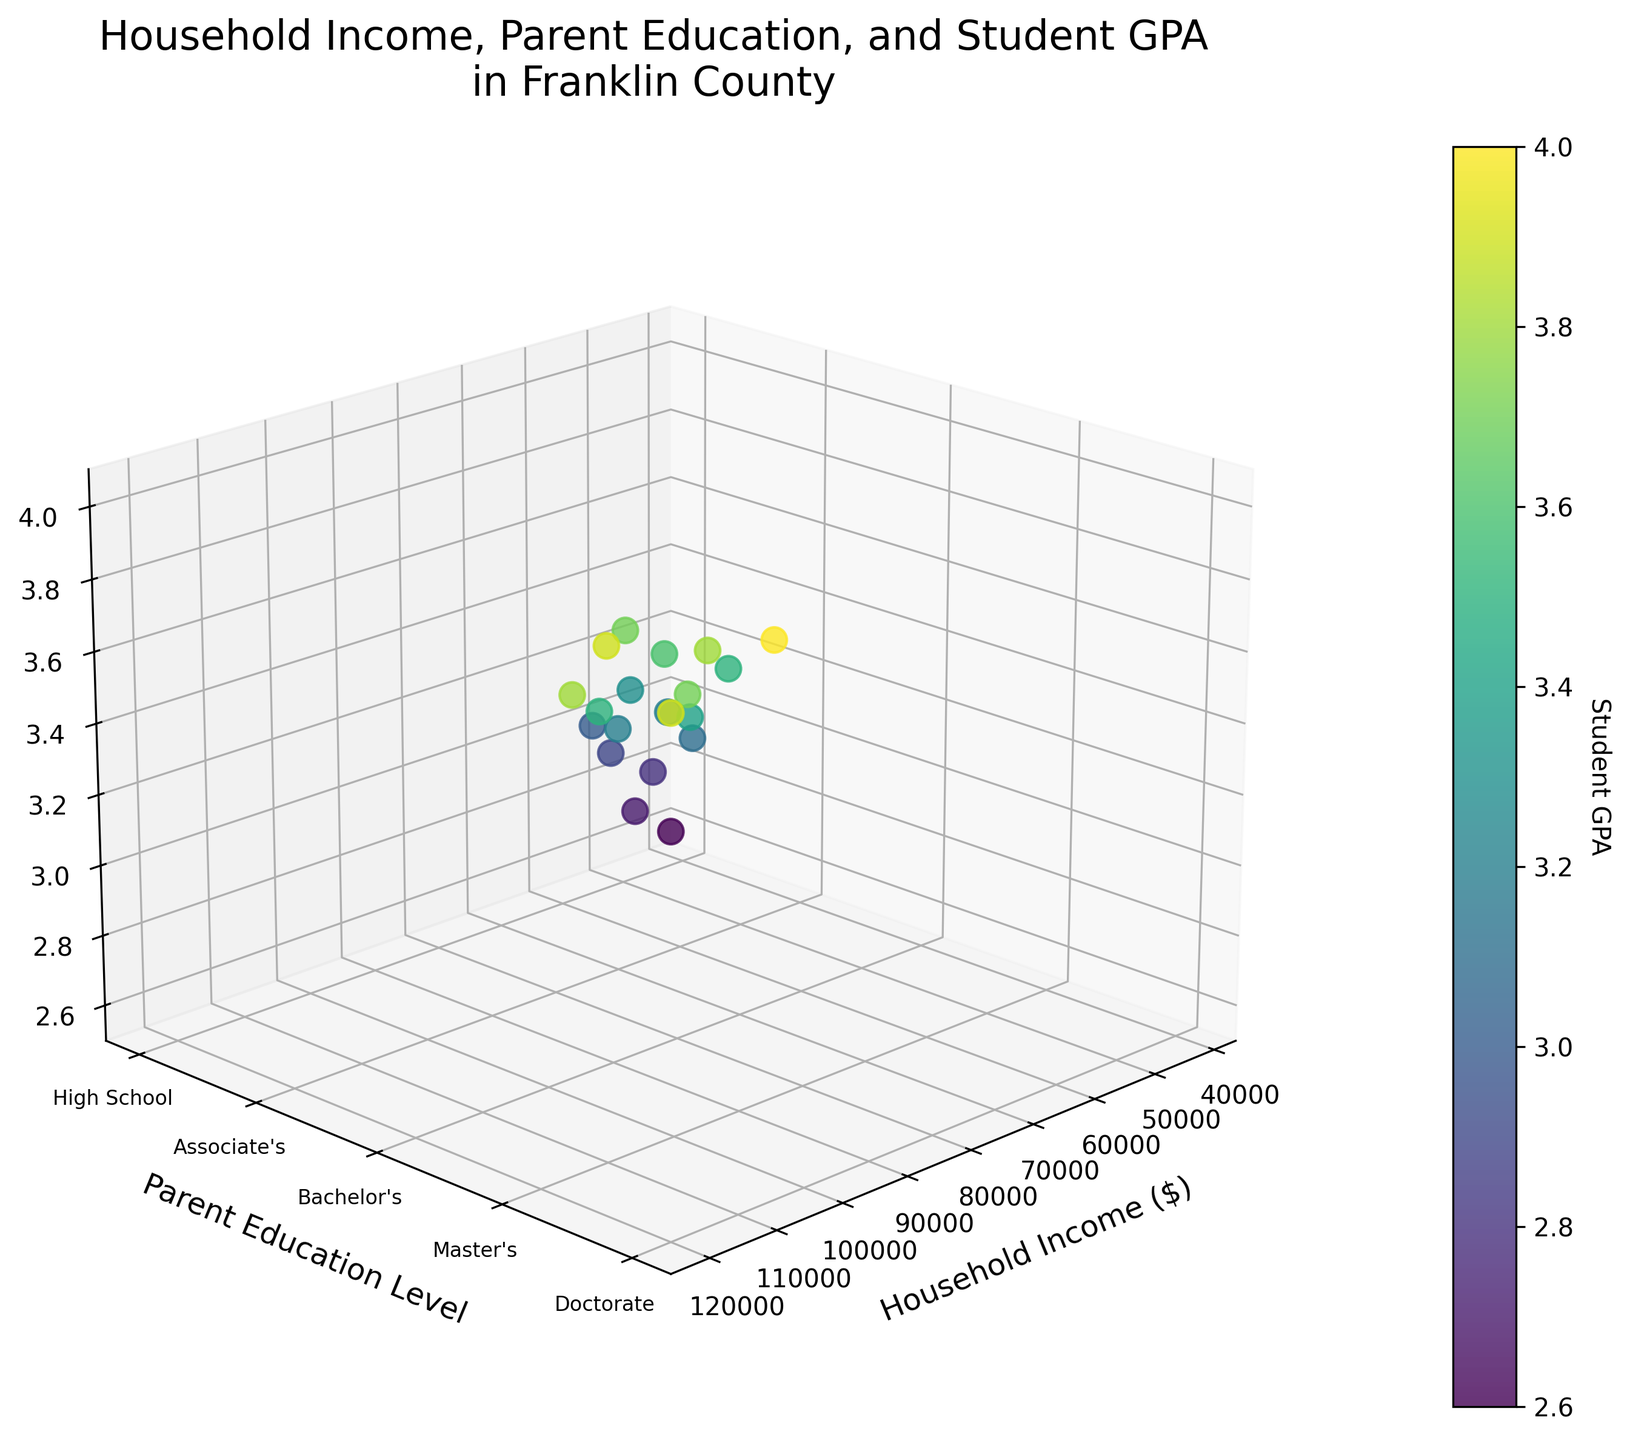what is the title of the figure? The title of the figure is usually displayed prominently at the top of the plot. It helps in understanding the main theme of the visualized data.
Answer: Household Income, Parent Education, and Student GPA in Franklin County What do the axes represent? The labels on the axes should indicate what they represent. In this plot, the x-axis represents Household Income, the y-axis represents Parent Education Level, and the z-axis represents Student GPA.
Answer: Household Income, Parent Education Level, and Student GPA How many data points are in the plot? Count the individual scatter points in the figure. Each point represents a combination of a household's income, a parent's education level, and a student's GPA. There are 20 data points in total.
Answer: 20 Which parent education level appears most frequently? Look at the y-axis labels and count the number of scatter points that fall into each category. The education level with the most points is "Bachelor's Degree" with 5 occurrences.
Answer: Bachelor's Degree What is the approximate GPA for a household income of $105,000? Locate the data point on the x-axis corresponding to $105,000. Then, trace vertically to see the GPA value, which is approximately 4.0.
Answer: 4.0 How does the GPA vary with higher parent education levels? Observe the z-axis (GPA) as the y-axis (Parent Education Level) increases. Generally, student GPA tends to increase with higher parent education levels.
Answer: GPA increases Which data point corresponds to the highest household income and what is the associated GPA? Identify the point on the x-axis with the highest value. The highest household income is $120,000, and the associated GPA for this point is 3.9.
Answer: $120,000 and 3.9 What is the color gradient indicative of in the scatter plot? Look at the color bar next to the plot, which maps GPA to colors. Darker colors indicate higher GPA values. This helps in visually distinguishing GPA levels across the data points.
Answer: Student GPA What is the gap in GPA between students whose parents have a Master's Degree and a High School education? Find the average GPA for students with a Master's Degree and those with only a High School education. Master's Degree average is about 3.8 and High School is about 2.75. The gap is approximately 1.05.
Answer: 1.05 Is there a correlation between increased household income and student GPA? Observe the overall trend in the scatter plot as you move from lower to higher household incomes on the x-axis. Generally, there is a positive correlation where increased income often correlates with a higher GPA.
Answer: Yes 